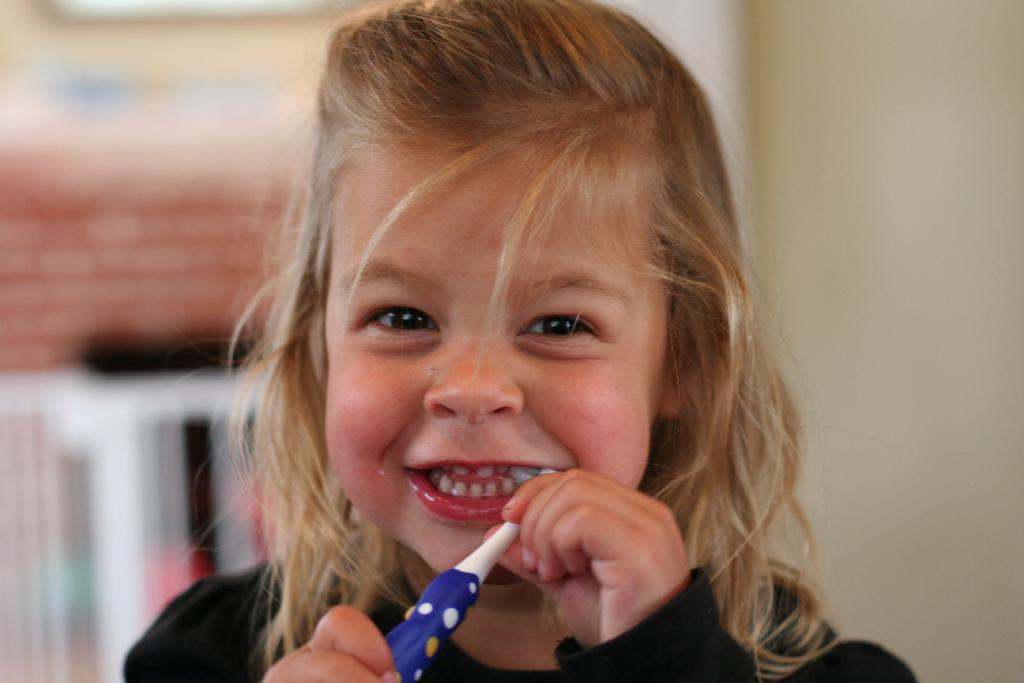What is the person in the image holding? The person is holding a brush in the image. What color is the shirt the person is wearing? The person is wearing a black color shirt. Can you describe the background of the image? The background of the image is blurred. What type of train can be seen in the background of the image? There is no train visible in the background of the image; the background is blurred. 